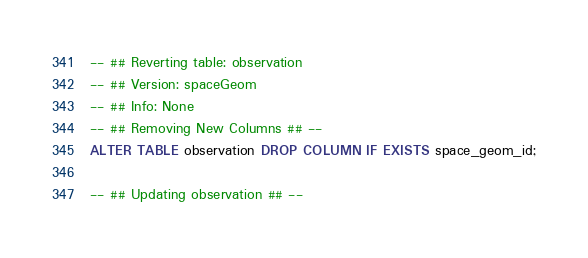<code> <loc_0><loc_0><loc_500><loc_500><_SQL_>-- ## Reverting table: observation
-- ## Version: spaceGeom
-- ## Info: None
-- ## Removing New Columns ## --
ALTER TABLE observation DROP COLUMN IF EXISTS space_geom_id;

-- ## Updating observation ## --
</code> 